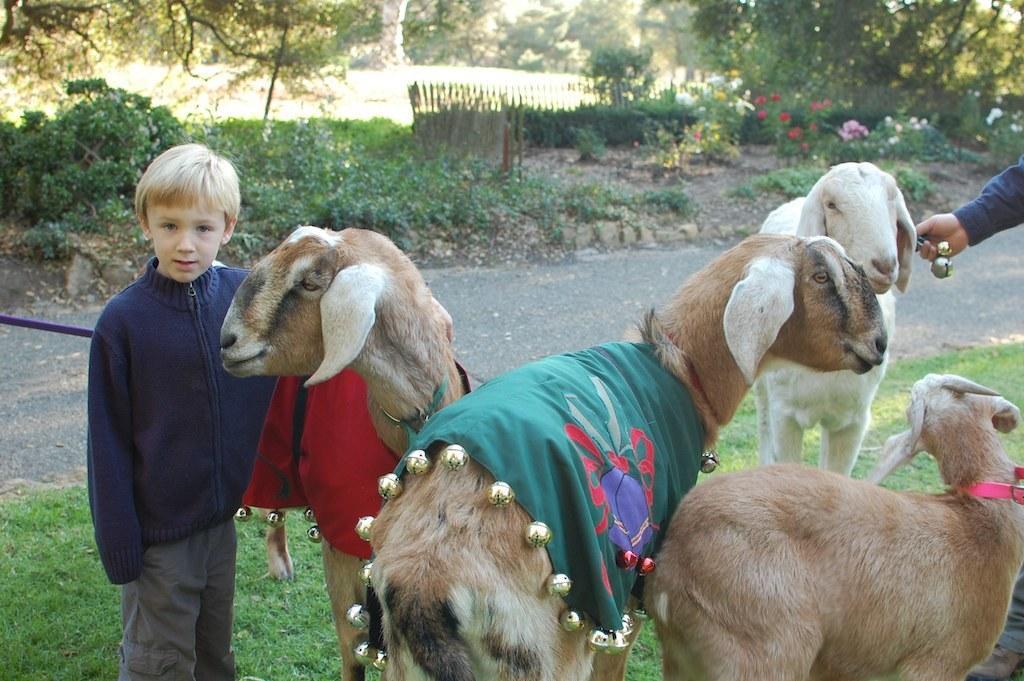Can you describe this image briefly? As we can see in the image there are animals, a boy wearing blue color jacket, grass, fence and trees. 